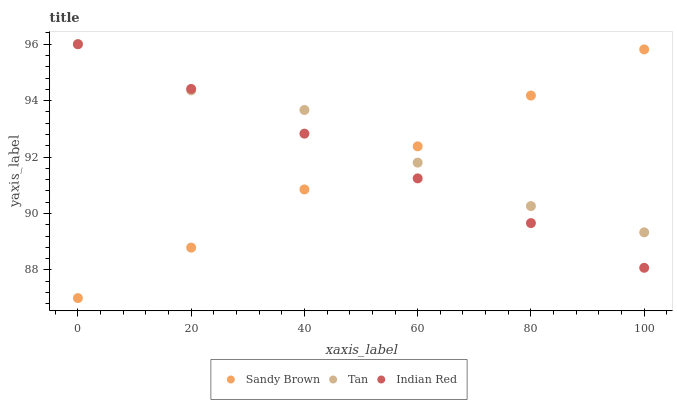Does Sandy Brown have the minimum area under the curve?
Answer yes or no. Yes. Does Tan have the maximum area under the curve?
Answer yes or no. Yes. Does Indian Red have the minimum area under the curve?
Answer yes or no. No. Does Indian Red have the maximum area under the curve?
Answer yes or no. No. Is Indian Red the smoothest?
Answer yes or no. Yes. Is Tan the roughest?
Answer yes or no. Yes. Is Sandy Brown the smoothest?
Answer yes or no. No. Is Sandy Brown the roughest?
Answer yes or no. No. Does Sandy Brown have the lowest value?
Answer yes or no. Yes. Does Indian Red have the lowest value?
Answer yes or no. No. Does Indian Red have the highest value?
Answer yes or no. Yes. Does Sandy Brown have the highest value?
Answer yes or no. No. Does Indian Red intersect Tan?
Answer yes or no. Yes. Is Indian Red less than Tan?
Answer yes or no. No. Is Indian Red greater than Tan?
Answer yes or no. No. 